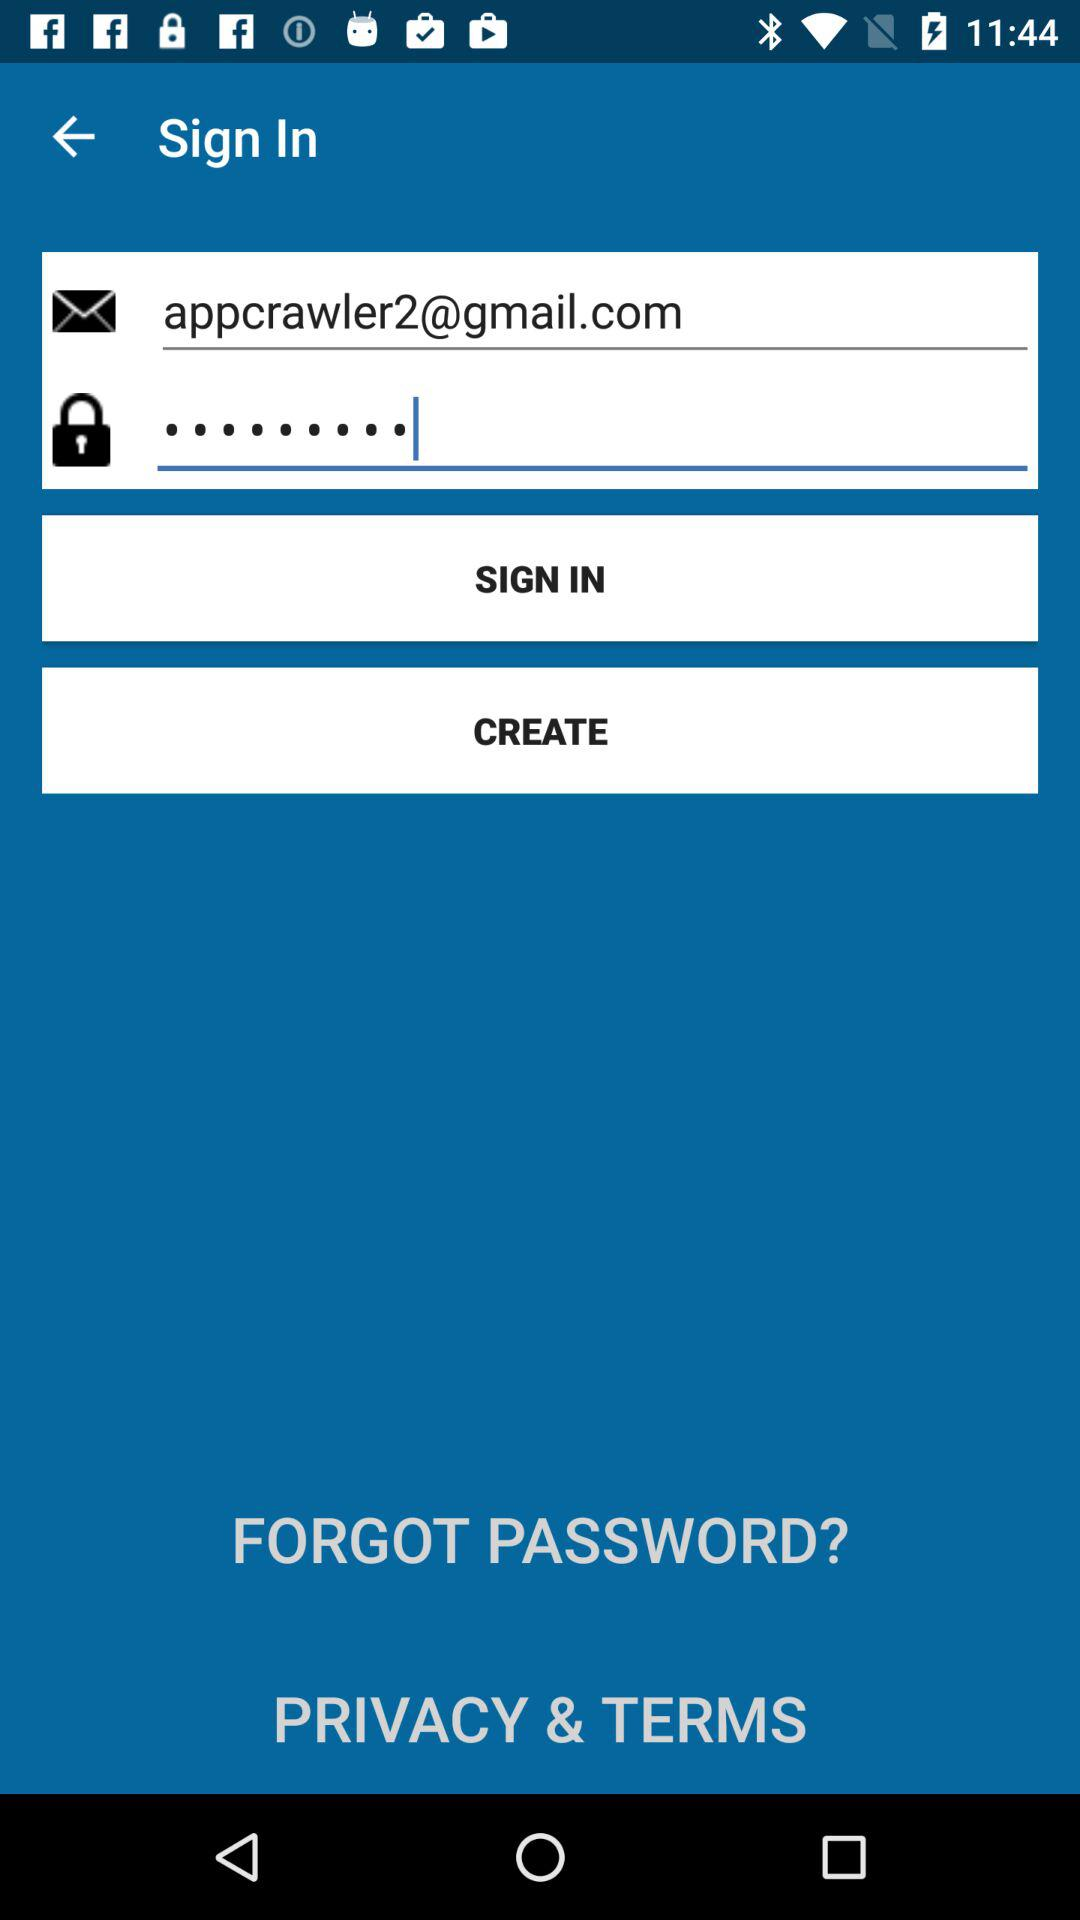What is the email address? The email address is "appcrawler2@gmail.com". 